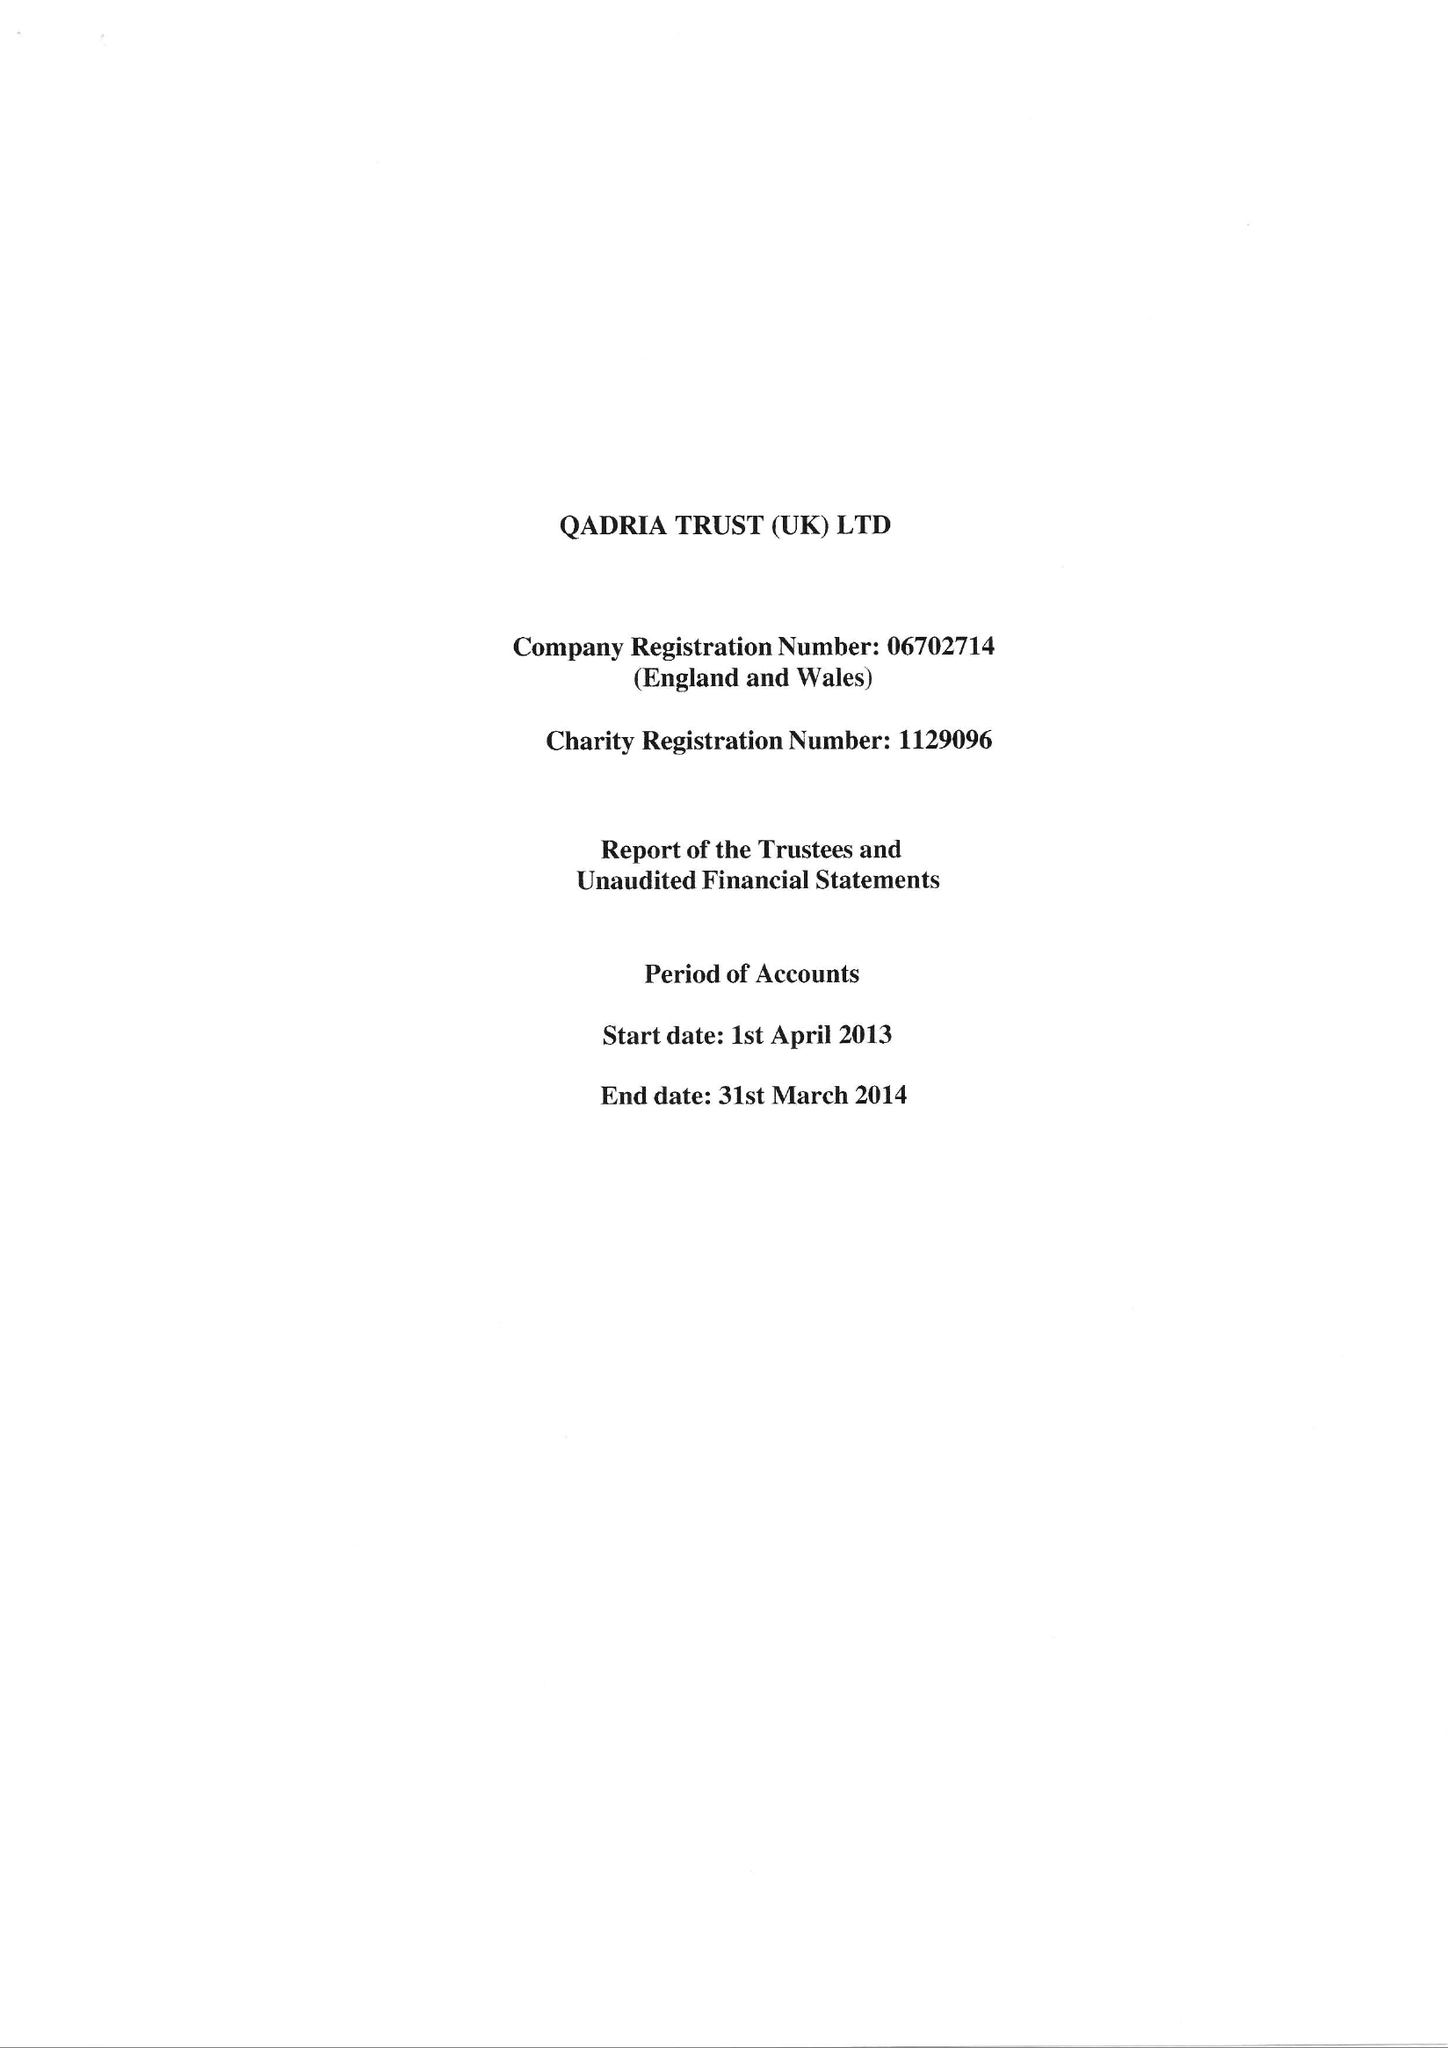What is the value for the spending_annually_in_british_pounds?
Answer the question using a single word or phrase. 56812.00 